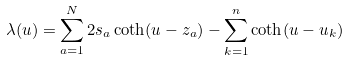Convert formula to latex. <formula><loc_0><loc_0><loc_500><loc_500>\lambda ( u ) = \sum _ { a = 1 } ^ { N } 2 s _ { a } \coth ( u - z _ { a } ) - \sum _ { k = 1 } ^ { n } \coth ( u - u _ { k } )</formula> 